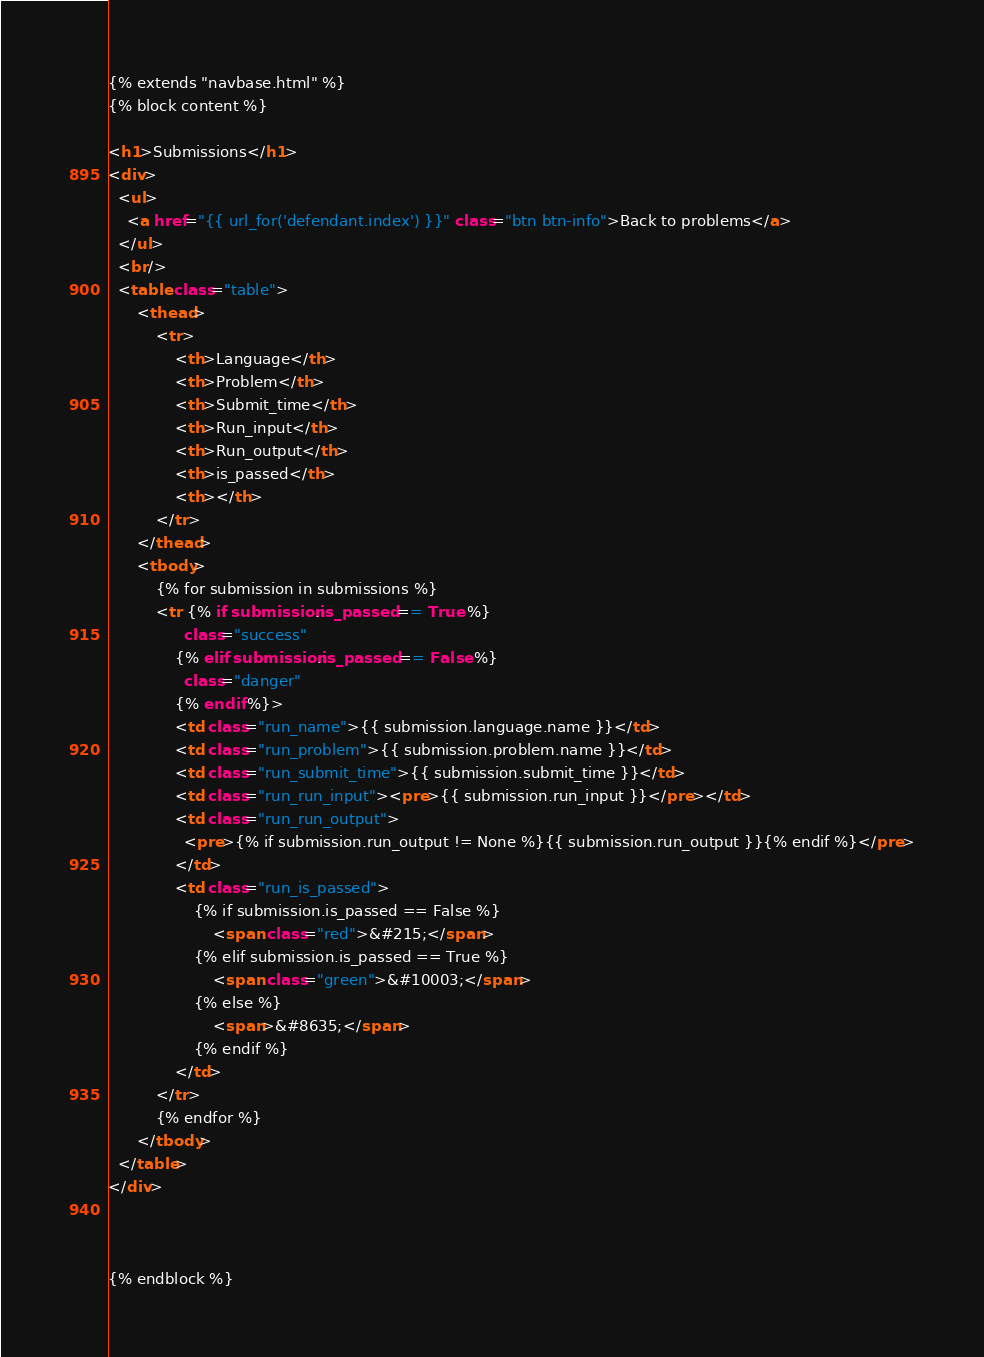Convert code to text. <code><loc_0><loc_0><loc_500><loc_500><_HTML_>{% extends "navbase.html" %}
{% block content %}

<h1>Submissions</h1>
<div>
  <ul>
    <a href="{{ url_for('defendant.index') }}" class="btn btn-info">Back to problems</a>
  </ul>
  <br/>
  <table class="table">
      <thead>
          <tr>
              <th>Language</th>
              <th>Problem</th>
              <th>Submit_time</th>
              <th>Run_input</th>
              <th>Run_output</th>
              <th>is_passed</th>
              <th></th>
          </tr>
      </thead>
      <tbody>
          {% for submission in submissions %}
          <tr {% if submission.is_passed == True %}
                class="success"
              {% elif submission.is_passed == False %}
                class="danger"
              {% endif %}>
              <td class="run_name">{{ submission.language.name }}</td>
              <td class="run_problem">{{ submission.problem.name }}</td>
              <td class="run_submit_time">{{ submission.submit_time }}</td>
              <td class="run_run_input"><pre>{{ submission.run_input }}</pre></td>
              <td class="run_run_output">
                <pre>{% if submission.run_output != None %}{{ submission.run_output }}{% endif %}</pre>
              </td>
              <td class="run_is_passed">
                  {% if submission.is_passed == False %}
                      <span class="red">&#215;</span>
                  {% elif submission.is_passed == True %}
                      <span class="green">&#10003;</span>
                  {% else %}
                      <span>&#8635;</span>
                  {% endif %}
              </td>
          </tr>
          {% endfor %}
      </tbody>
  </table>
</div>



{% endblock %}
</code> 